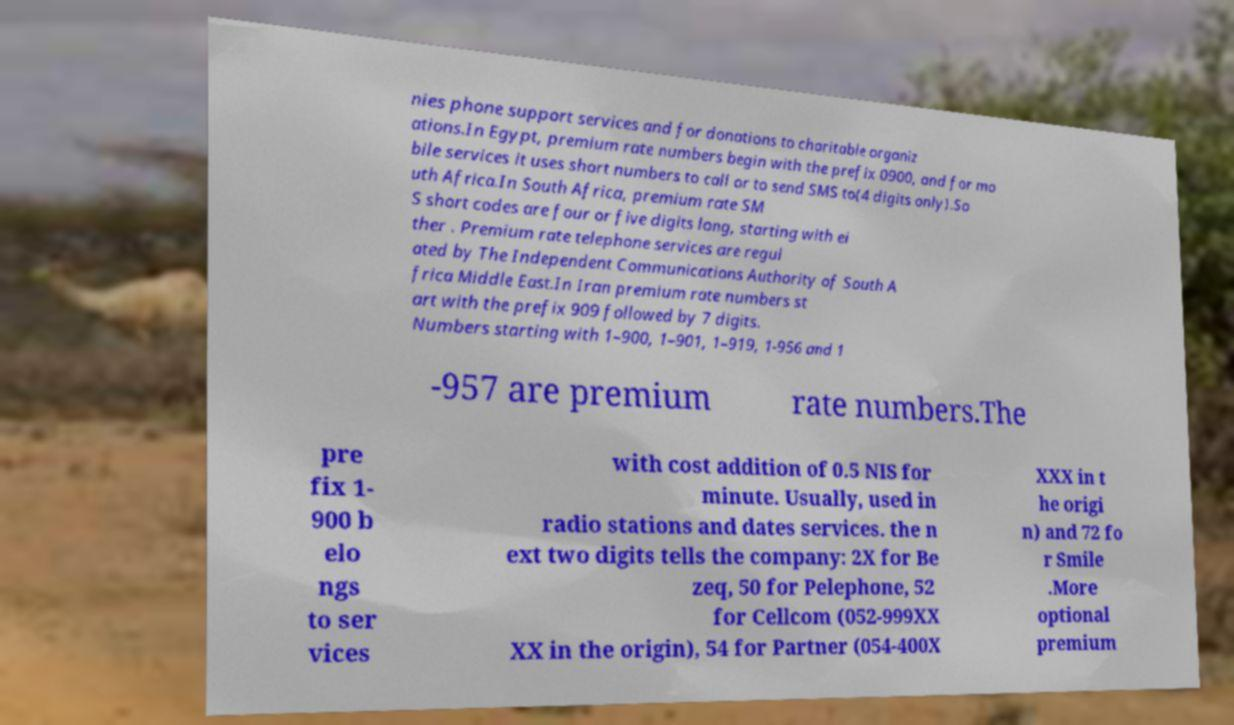Please read and relay the text visible in this image. What does it say? nies phone support services and for donations to charitable organiz ations.In Egypt, premium rate numbers begin with the prefix 0900, and for mo bile services it uses short numbers to call or to send SMS to(4 digits only).So uth Africa.In South Africa, premium rate SM S short codes are four or five digits long, starting with ei ther . Premium rate telephone services are regul ated by The Independent Communications Authority of South A frica Middle East.In Iran premium rate numbers st art with the prefix 909 followed by 7 digits. Numbers starting with 1–900, 1–901, 1–919, 1-956 and 1 -957 are premium rate numbers.The pre fix 1- 900 b elo ngs to ser vices with cost addition of 0.5 NIS for minute. Usually, used in radio stations and dates services. the n ext two digits tells the company: 2X for Be zeq, 50 for Pelephone, 52 for Cellcom (052-999XX XX in the origin), 54 for Partner (054-400X XXX in t he origi n) and 72 fo r Smile .More optional premium 